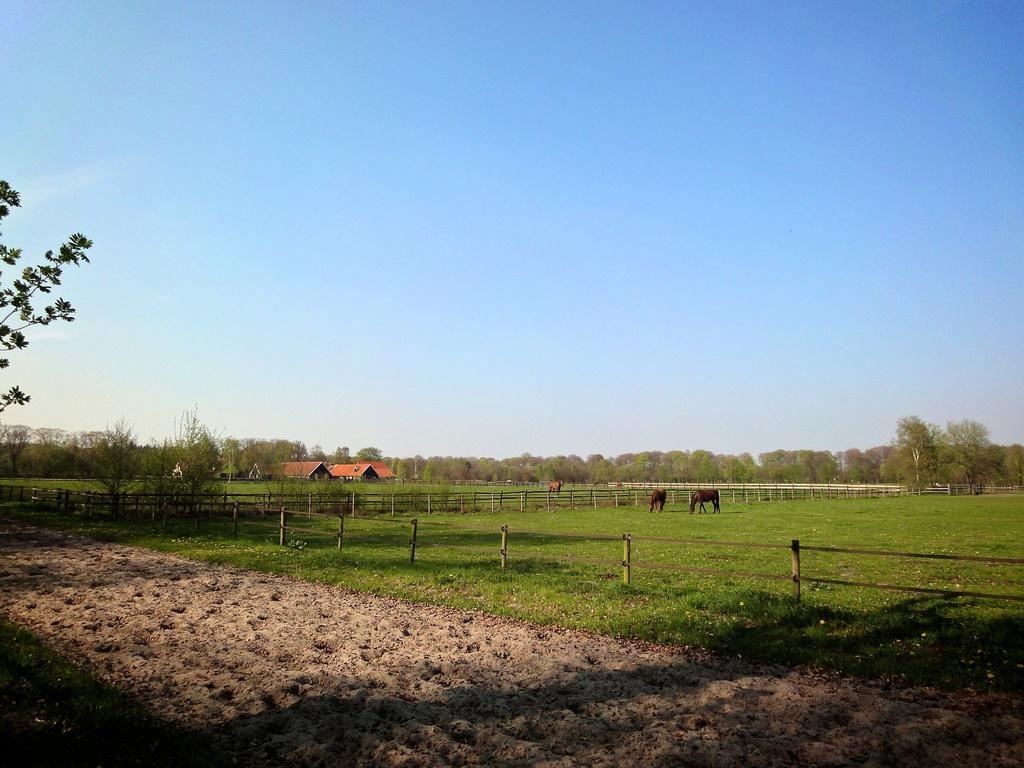What type of vegetation is present in the image? There is grass in the image. What structure can be seen surrounding the area in the image? There is a fence in the image. What living creatures are standing in the image? There are animals standing in the image. What type of buildings can be seen in the image? There are houses in the image. What other natural elements are present in the image? There are trees in the image. What is visible in the background of the image? The sky is visible in the background of the image. How many squirrels are pulling the rabbits in the image? There are no squirrels or rabbits present in the image. 